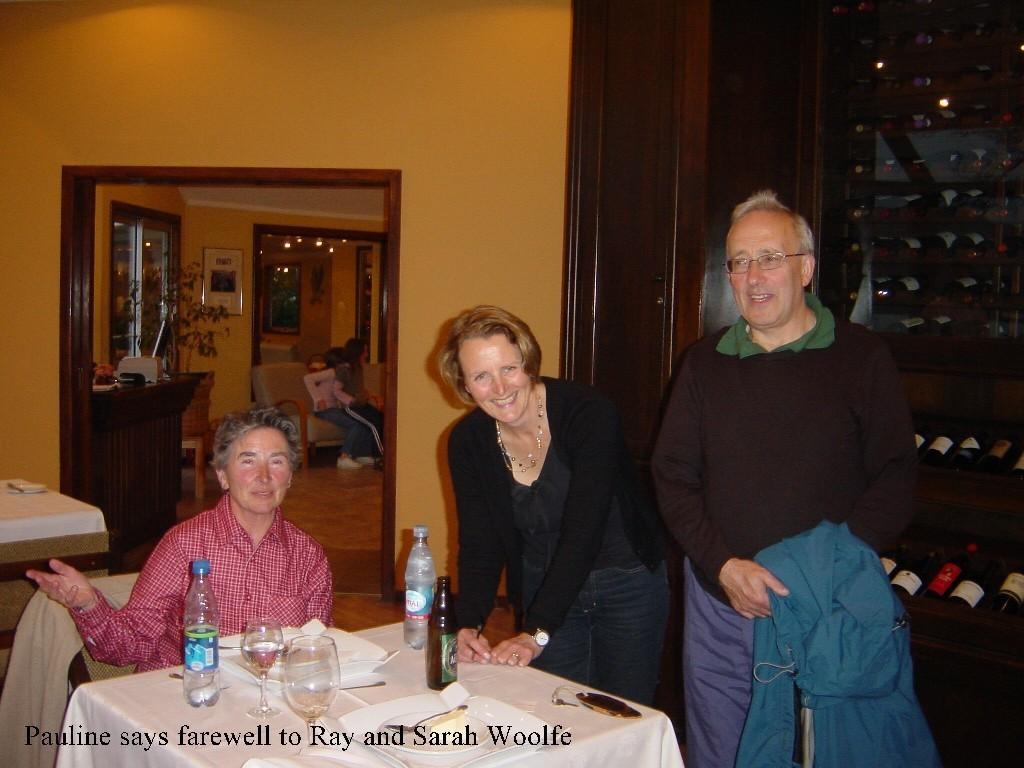In one or two sentences, can you explain what this image depicts? There is a group of people. The two persons are standing. They are smiling and remaining three persons are sitting on a chairs. We can see in the background wall,window,cupboard. 